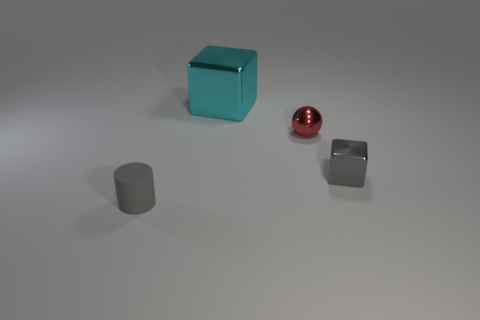What material is the tiny object that is the same shape as the large thing?
Your answer should be compact. Metal. What number of tiny cyan metal objects are there?
Offer a very short reply. 0. There is a tiny gray object to the right of the red thing; what shape is it?
Your response must be concise. Cube. What color is the object that is on the right side of the small thing behind the cube that is in front of the cyan metal cube?
Offer a terse response. Gray. The tiny red object that is the same material as the large cyan block is what shape?
Provide a short and direct response. Sphere. Is the number of red objects less than the number of gray things?
Provide a succinct answer. Yes. Is the material of the tiny sphere the same as the small gray cylinder?
Offer a very short reply. No. What number of other objects are the same color as the small rubber object?
Make the answer very short. 1. Is the number of cylinders greater than the number of cyan rubber things?
Your answer should be very brief. Yes. There is a rubber cylinder; does it have the same size as the metal thing behind the small red metallic ball?
Keep it short and to the point. No. 